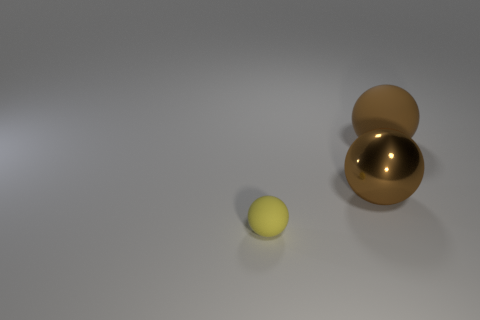Add 2 big green cubes. How many objects exist? 5 Add 3 big brown rubber balls. How many big brown rubber balls are left? 4 Add 3 big red blocks. How many big red blocks exist? 3 Subtract 0 purple spheres. How many objects are left? 3 Subtract all brown rubber objects. Subtract all tiny green cubes. How many objects are left? 2 